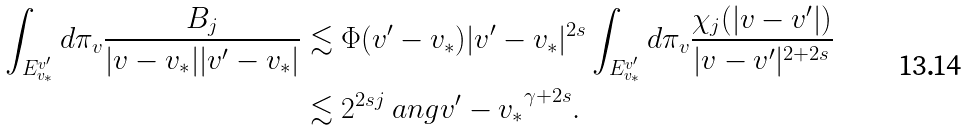Convert formula to latex. <formula><loc_0><loc_0><loc_500><loc_500>\int _ { E _ { v _ { * } } ^ { v ^ { \prime } } } d \pi _ { v } \frac { { B } _ { j } } { | v - v _ { * } | | v ^ { \prime } - v _ { * } | } & \lesssim \Phi ( v ^ { \prime } - v _ { * } ) | v ^ { \prime } - v _ { * } | ^ { 2 s } \int _ { E _ { v _ { * } } ^ { v ^ { \prime } } } d \pi _ { v } \frac { \chi _ { j } ( | v - v ^ { \prime } | ) } { | v - v ^ { \prime } | ^ { 2 + 2 s } } \\ & \lesssim 2 ^ { 2 s j } \ a n g { v ^ { \prime } - v _ { * } } ^ { \gamma + 2 s } .</formula> 